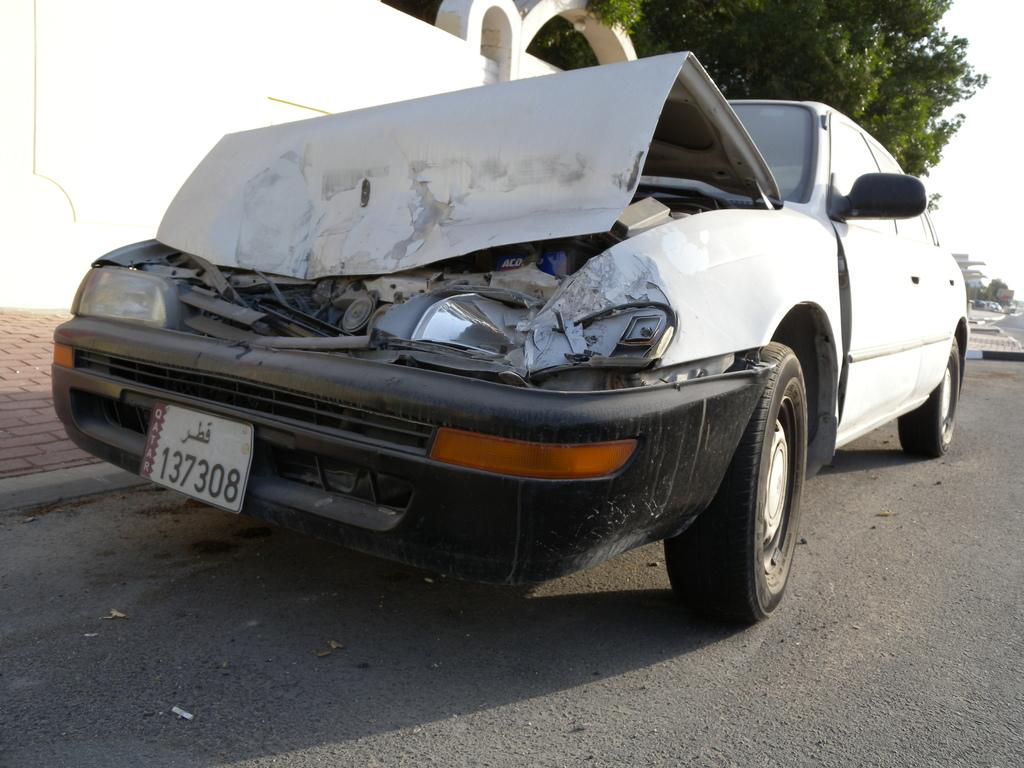<image>
Write a terse but informative summary of the picture. Wrecked Car at the front with a front license plate saying 137308. 